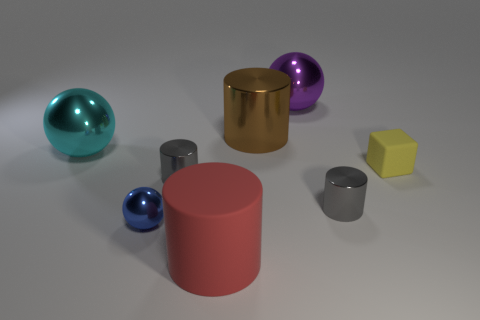Subtract all large rubber cylinders. How many cylinders are left? 3 Subtract all purple blocks. How many gray cylinders are left? 2 Add 1 tiny gray things. How many objects exist? 9 Subtract all brown cylinders. How many cylinders are left? 3 Subtract 0 blue cubes. How many objects are left? 8 Subtract all spheres. How many objects are left? 5 Subtract all cyan spheres. Subtract all blue cylinders. How many spheres are left? 2 Subtract all brown rubber cylinders. Subtract all large brown metal things. How many objects are left? 7 Add 2 rubber things. How many rubber things are left? 4 Add 3 blue rubber spheres. How many blue rubber spheres exist? 3 